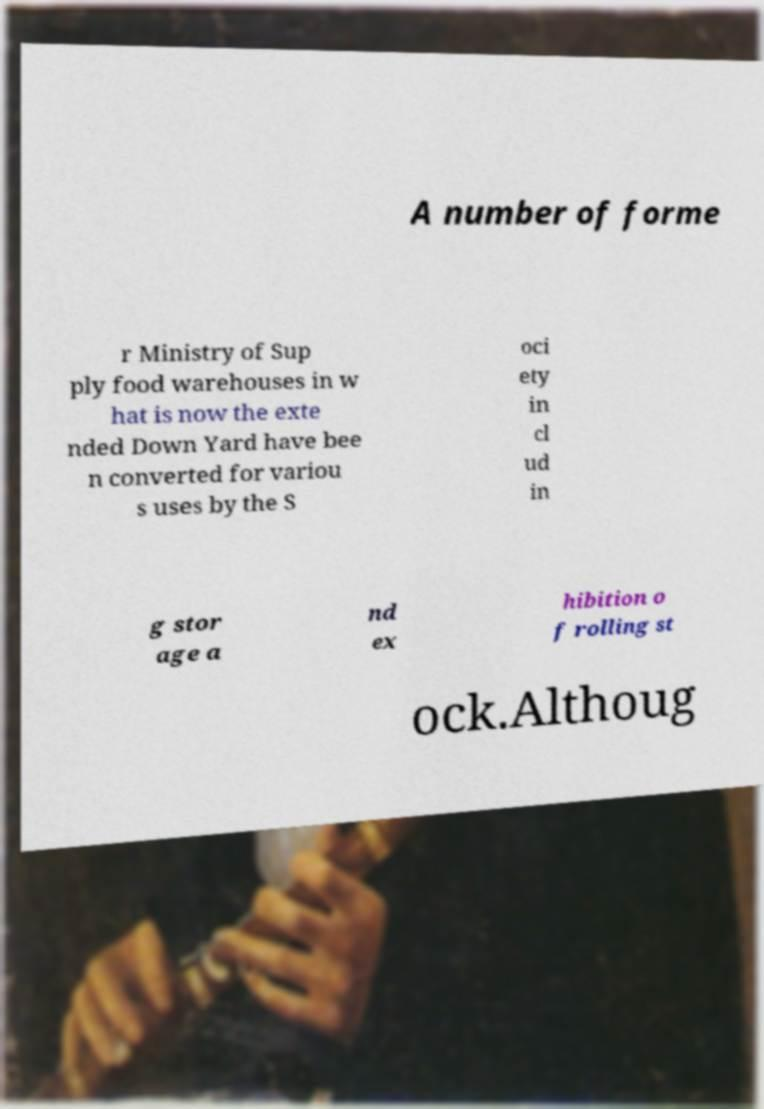Can you read and provide the text displayed in the image?This photo seems to have some interesting text. Can you extract and type it out for me? A number of forme r Ministry of Sup ply food warehouses in w hat is now the exte nded Down Yard have bee n converted for variou s uses by the S oci ety in cl ud in g stor age a nd ex hibition o f rolling st ock.Althoug 